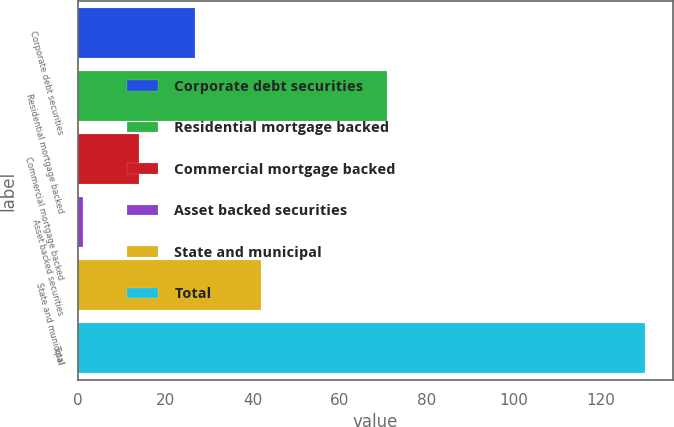Convert chart. <chart><loc_0><loc_0><loc_500><loc_500><bar_chart><fcel>Corporate debt securities<fcel>Residential mortgage backed<fcel>Commercial mortgage backed<fcel>Asset backed securities<fcel>State and municipal<fcel>Total<nl><fcel>26.8<fcel>71<fcel>13.9<fcel>1<fcel>42<fcel>130<nl></chart> 